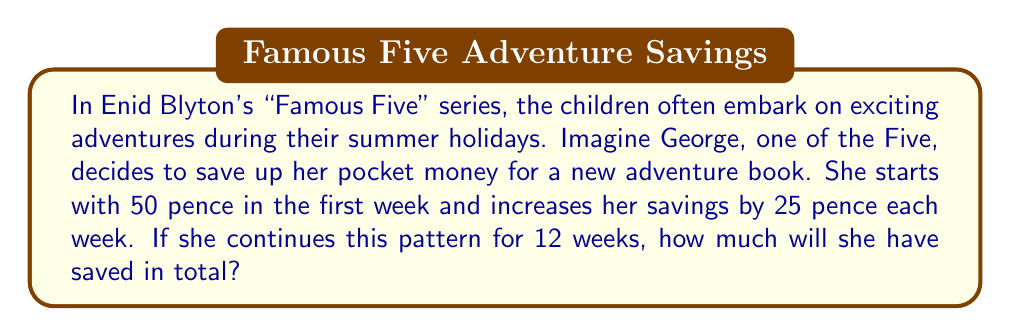Could you help me with this problem? Let's approach this problem using arithmetic sequence principles:

1) First, identify the components of the arithmetic sequence:
   - $a_1 = 50$ (first term, in pence)
   - $d = 25$ (common difference, in pence)
   - $n = 12$ (number of terms)

2) The last term of the sequence can be calculated using:
   $a_n = a_1 + (n-1)d$
   $a_{12} = 50 + (12-1)25 = 50 + 275 = 325$ pence

3) For an arithmetic sequence, we can use the formula for the sum:
   $S_n = \frac{n}{2}(a_1 + a_n)$

   Where:
   $S_n$ is the sum of the sequence
   $n$ is the number of terms
   $a_1$ is the first term
   $a_n$ is the last term

4) Substituting our values:
   $S_{12} = \frac{12}{2}(50 + 325)$
   $S_{12} = 6(375)$
   $S_{12} = 2250$ pence

5) Convert to pounds:
   $2250 \text{ pence} = £22.50$

Therefore, George will have saved a total of £22.50 after 12 weeks.
Answer: £22.50 